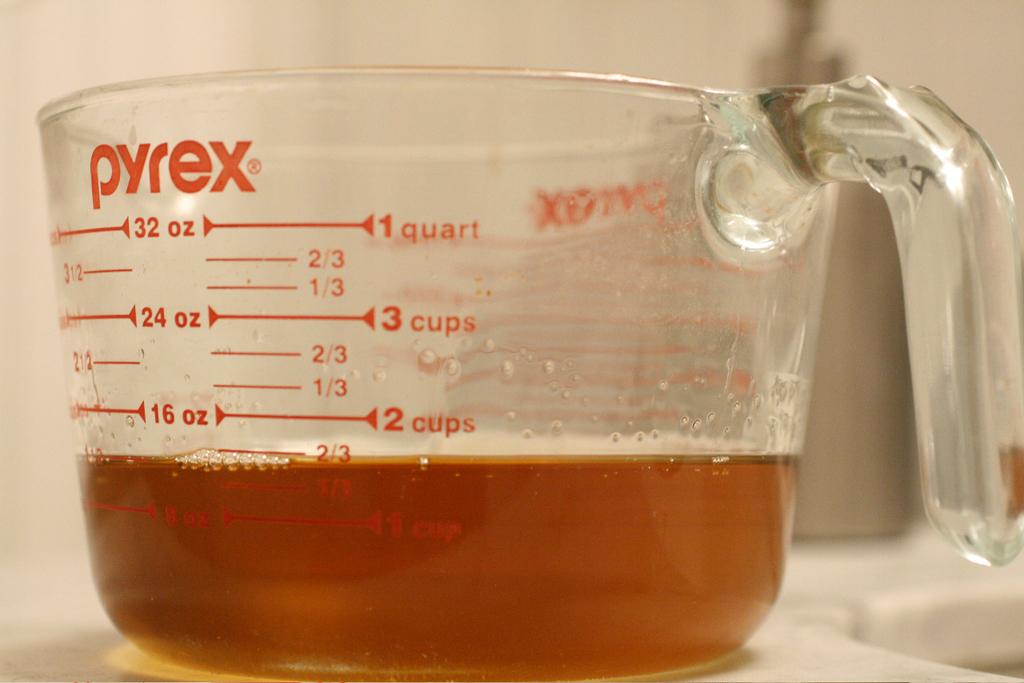Provide a one-sentence caption for the provided image. A Pyrex measuring cup is labeled with quart and cup measurements. 